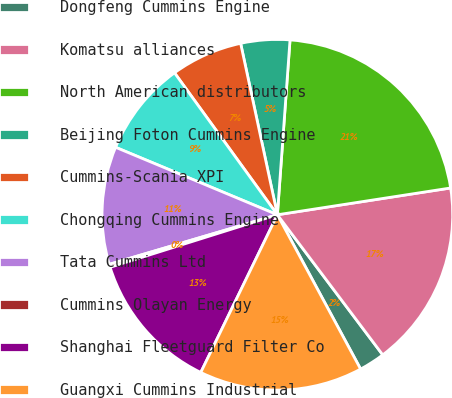Convert chart to OTSL. <chart><loc_0><loc_0><loc_500><loc_500><pie_chart><fcel>Dongfeng Cummins Engine<fcel>Komatsu alliances<fcel>North American distributors<fcel>Beijing Foton Cummins Engine<fcel>Cummins-Scania XPI<fcel>Chongqing Cummins Engine<fcel>Tata Cummins Ltd<fcel>Cummins Olayan Energy<fcel>Shanghai Fleetguard Filter Co<fcel>Guangxi Cummins Industrial<nl><fcel>2.39%<fcel>17.18%<fcel>21.41%<fcel>4.51%<fcel>6.62%<fcel>8.73%<fcel>10.85%<fcel>0.28%<fcel>12.96%<fcel>15.07%<nl></chart> 